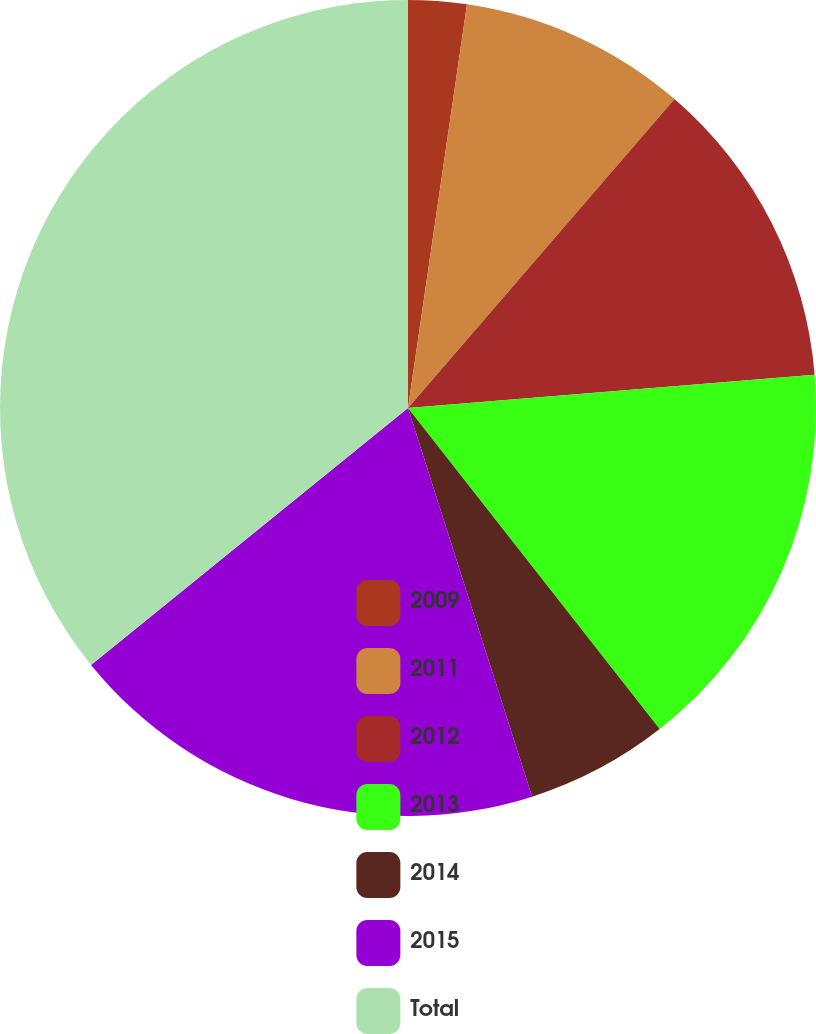Convert chart. <chart><loc_0><loc_0><loc_500><loc_500><pie_chart><fcel>2009<fcel>2011<fcel>2012<fcel>2013<fcel>2014<fcel>2015<fcel>Total<nl><fcel>2.31%<fcel>9.02%<fcel>12.37%<fcel>15.72%<fcel>5.66%<fcel>19.08%<fcel>35.84%<nl></chart> 